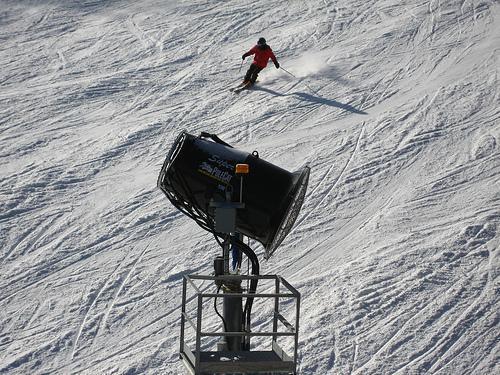How many people are in the photo?
Give a very brief answer. 1. 